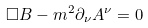<formula> <loc_0><loc_0><loc_500><loc_500>\square B - m ^ { 2 } \partial _ { \nu } A ^ { \nu } = 0</formula> 